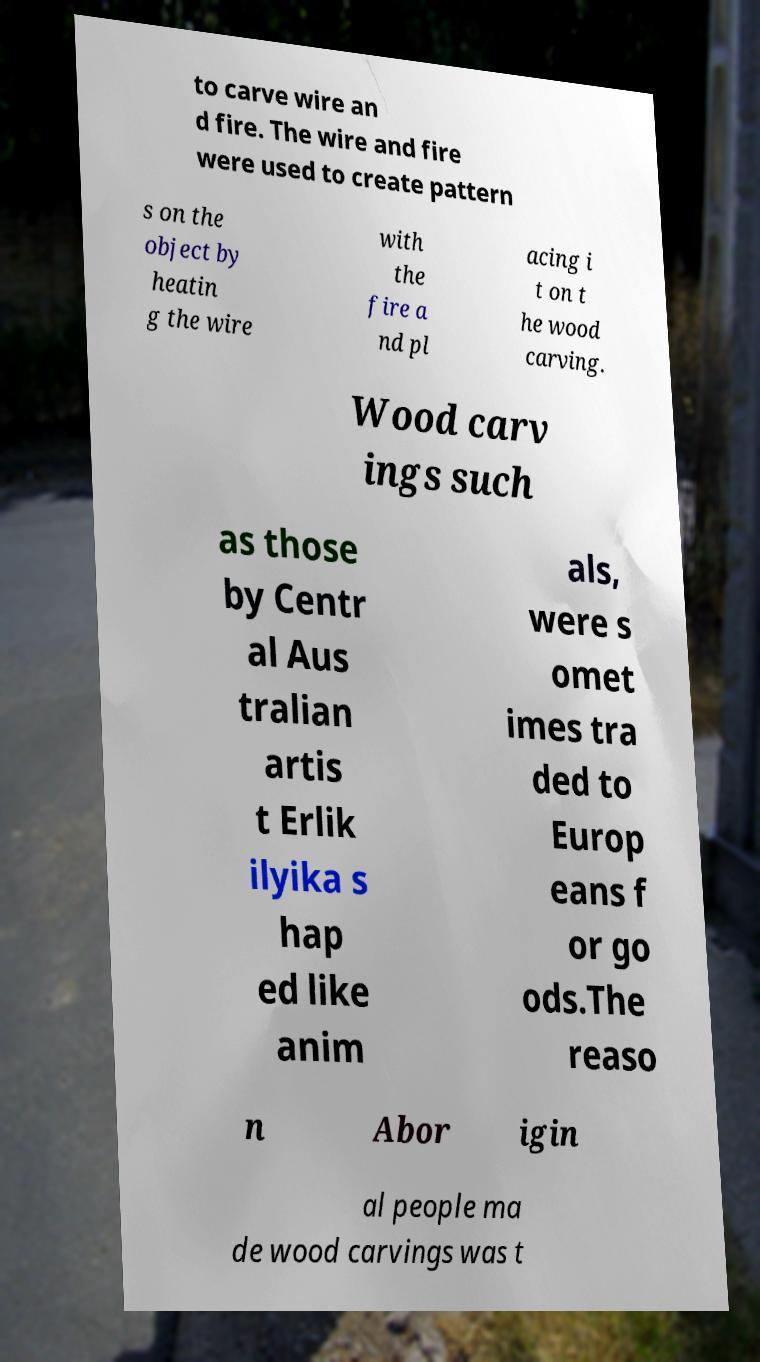There's text embedded in this image that I need extracted. Can you transcribe it verbatim? to carve wire an d fire. The wire and fire were used to create pattern s on the object by heatin g the wire with the fire a nd pl acing i t on t he wood carving. Wood carv ings such as those by Centr al Aus tralian artis t Erlik ilyika s hap ed like anim als, were s omet imes tra ded to Europ eans f or go ods.The reaso n Abor igin al people ma de wood carvings was t 